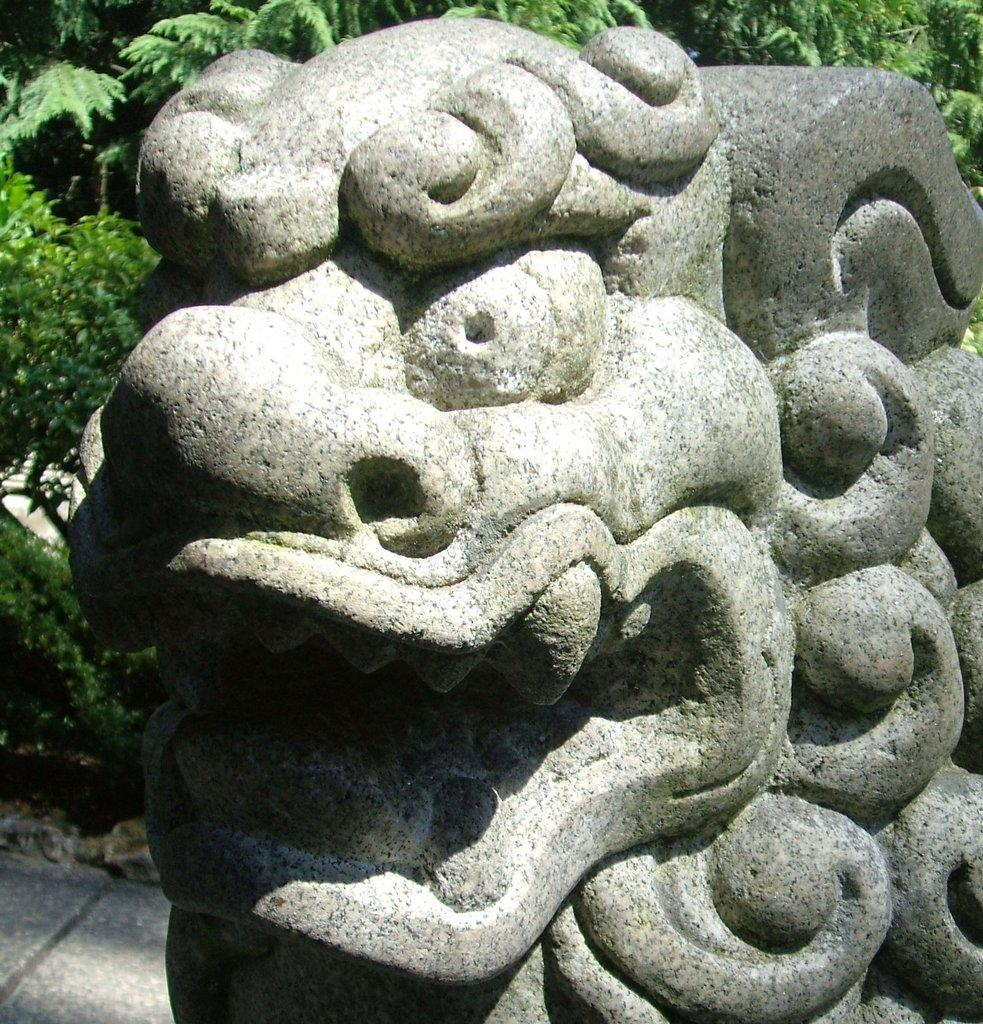What is the main subject of the image? The main subject of the image is a stone carving. Can you describe the setting of the image? There are trees visible in the background of the image. How many cows are grazing in the foreground of the image? There are no cows present in the image; it features a stone carving and trees in the background. 